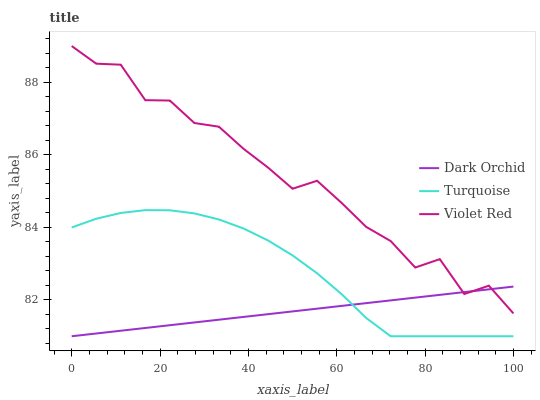Does Dark Orchid have the minimum area under the curve?
Answer yes or no. Yes. Does Violet Red have the maximum area under the curve?
Answer yes or no. Yes. Does Violet Red have the minimum area under the curve?
Answer yes or no. No. Does Dark Orchid have the maximum area under the curve?
Answer yes or no. No. Is Dark Orchid the smoothest?
Answer yes or no. Yes. Is Violet Red the roughest?
Answer yes or no. Yes. Is Violet Red the smoothest?
Answer yes or no. No. Is Dark Orchid the roughest?
Answer yes or no. No. Does Turquoise have the lowest value?
Answer yes or no. Yes. Does Violet Red have the lowest value?
Answer yes or no. No. Does Violet Red have the highest value?
Answer yes or no. Yes. Does Dark Orchid have the highest value?
Answer yes or no. No. Is Turquoise less than Violet Red?
Answer yes or no. Yes. Is Violet Red greater than Turquoise?
Answer yes or no. Yes. Does Dark Orchid intersect Turquoise?
Answer yes or no. Yes. Is Dark Orchid less than Turquoise?
Answer yes or no. No. Is Dark Orchid greater than Turquoise?
Answer yes or no. No. Does Turquoise intersect Violet Red?
Answer yes or no. No. 